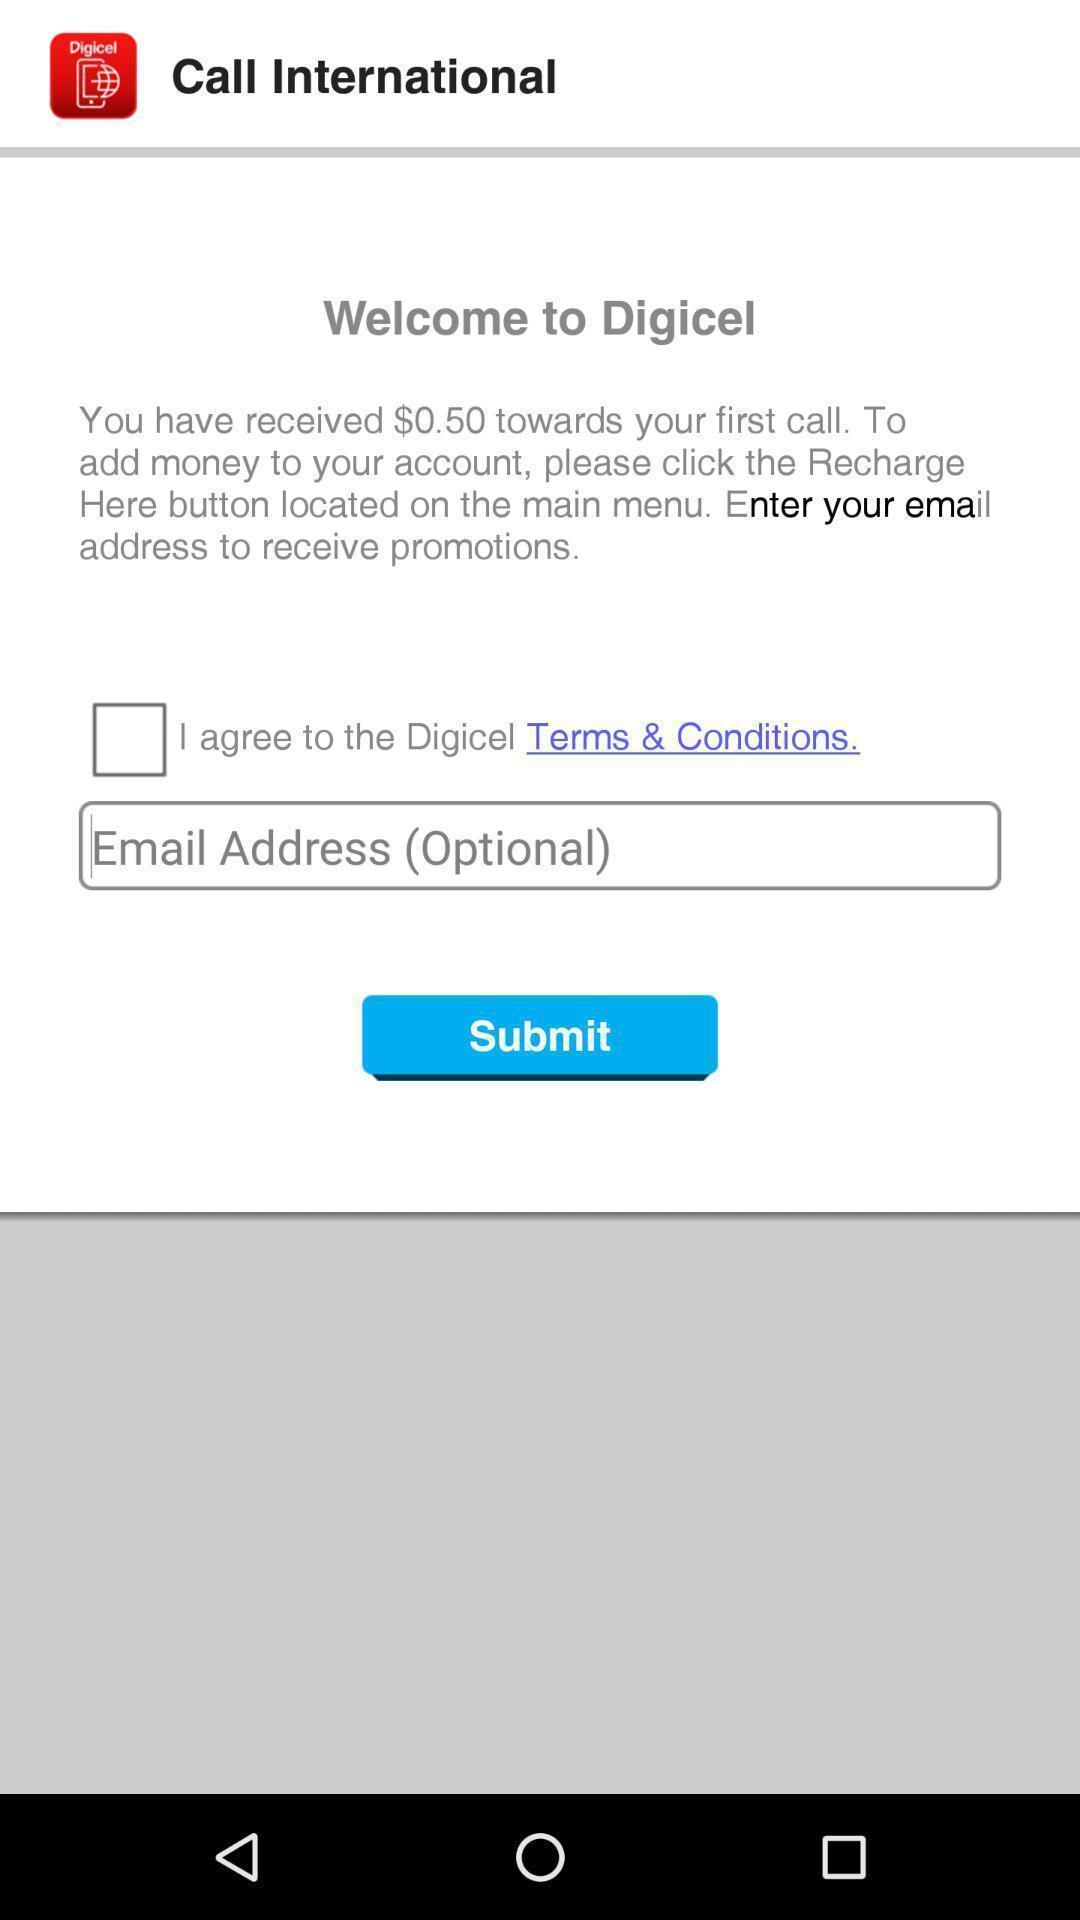Tell me about the visual elements in this screen capture. Welcome page of a call app. 